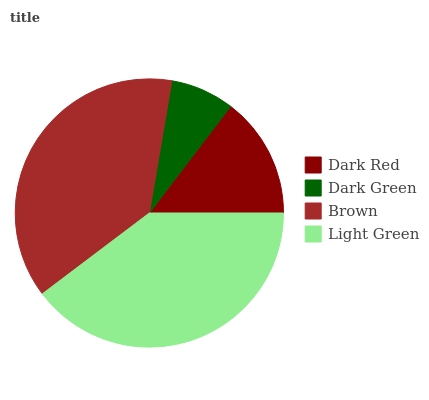Is Dark Green the minimum?
Answer yes or no. Yes. Is Light Green the maximum?
Answer yes or no. Yes. Is Brown the minimum?
Answer yes or no. No. Is Brown the maximum?
Answer yes or no. No. Is Brown greater than Dark Green?
Answer yes or no. Yes. Is Dark Green less than Brown?
Answer yes or no. Yes. Is Dark Green greater than Brown?
Answer yes or no. No. Is Brown less than Dark Green?
Answer yes or no. No. Is Brown the high median?
Answer yes or no. Yes. Is Dark Red the low median?
Answer yes or no. Yes. Is Dark Green the high median?
Answer yes or no. No. Is Light Green the low median?
Answer yes or no. No. 